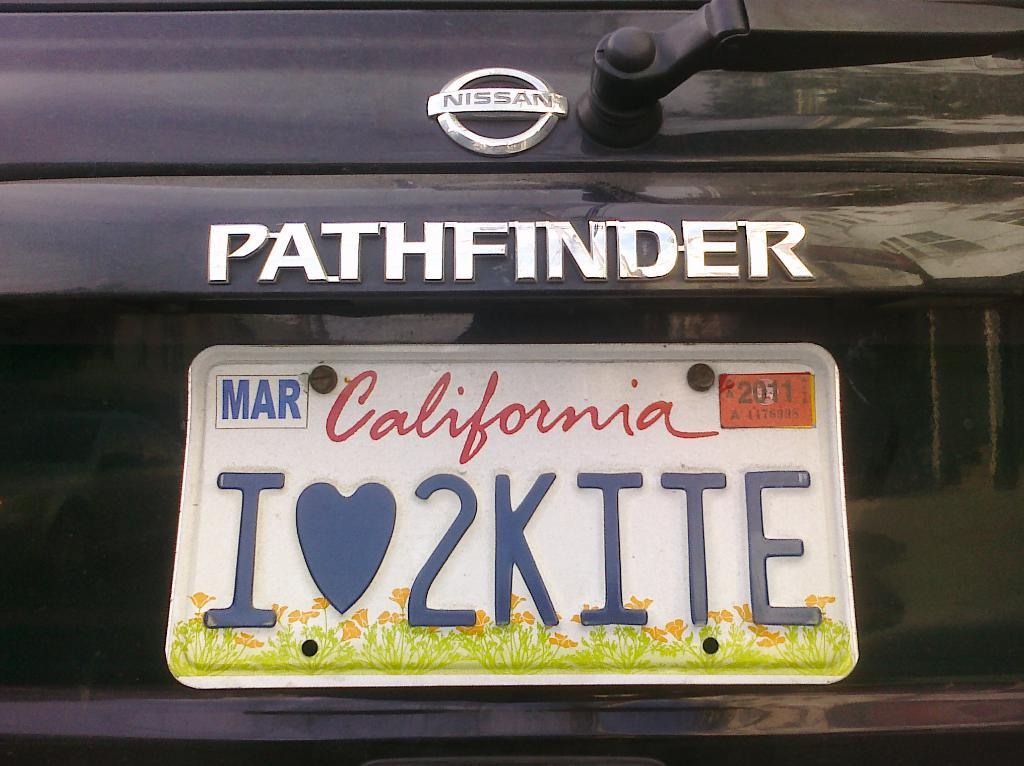<image>
Describe the image concisely. A Pathfinder has a California license plate with "Ilove2kite" written on it 